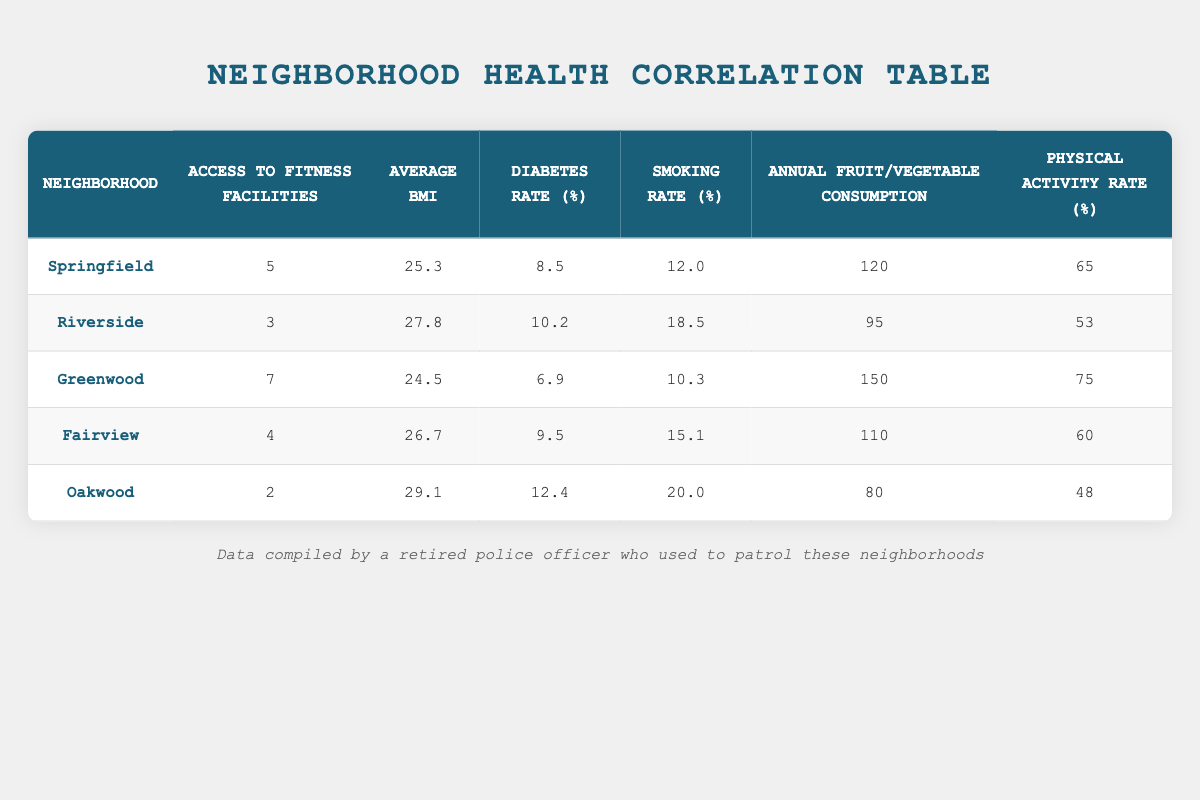What is the average BMI across all neighborhoods? To find the average BMI, I will sum all the average BMIs (25.3 + 27.8 + 24.5 + 26.7 + 29.1 = 133.4) and divide by the number of neighborhoods (5). So, the average BMI is 133.4 / 5 = 26.68.
Answer: 26.68 Which neighborhood has the highest smoking rate? I will review the smoking rates from each neighborhood, which are: Springfield (12.0), Riverside (18.5), Greenwood (10.3), Fairview (15.1), and Oakwood (20.0). The highest smoking rate is in Oakwood.
Answer: Oakwood Is there a neighborhood that has both the highest access to fitness facilities and the lowest diabetes rate? I first identify the neighborhood with the highest access to fitness facilities, which is Greenwood (7), and check its diabetes rate (6.9). Comparing this with other neighborhoods, Greenwood indeed has the lowest diabetes rate alongside the highest access to fitness facilities.
Answer: Yes What is the diabetes rate in Riverside, and how does it compare to the neighborhood with the lowest diabetes rate? The diabetes rate in Riverside is 10.2. The neighborhood with the lowest diabetes rate is Greenwood, with a rate of 6.9. To compare: Riverside (10.2) is higher than Greenwood (6.9) by 3.3.
Answer: 10.2; higher by 3.3 How does the physical activity rate correlate with access to fitness facilities in Greenwood? In Greenwood, the access to fitness facilities is 7, and the physical activity rate is 75. This indicates a positive correlation, as higher access to facilities aligns with increased physical activity (75 is significantly higher than the physical activity rates in neighborhoods with less access).
Answer: Positive correlation What is the total annual fruit and vegetable consumption for all neighborhoods, and how does it compare to the average? I sum up the annual fruit and vegetable consumption: (120 + 95 + 150 + 110 + 80 = 555). The average consumption is 555 / 5 = 111. The total (555) shows significant engagement with fruits and vegetables in these communities.
Answer: Total: 555; Average: 111 Is the average BMI for the neighborhood with the highest access to fitness facilities lower than 26? The neighborhood with the highest access to fitness facilities is Greenwood with an average BMI of 24.5, which is lower than 26. Therefore, this statement holds true.
Answer: Yes In which neighborhood does the average BMI exceed 28? I will check the average BMI for all neighborhoods: Springfield (25.3), Riverside (27.8), Greenwood (24.5), Fairview (26.7), and Oakwood (29.1). The only neighborhood with an average BMI exceeding 28 is Oakwood (29.1).
Answer: Oakwood 